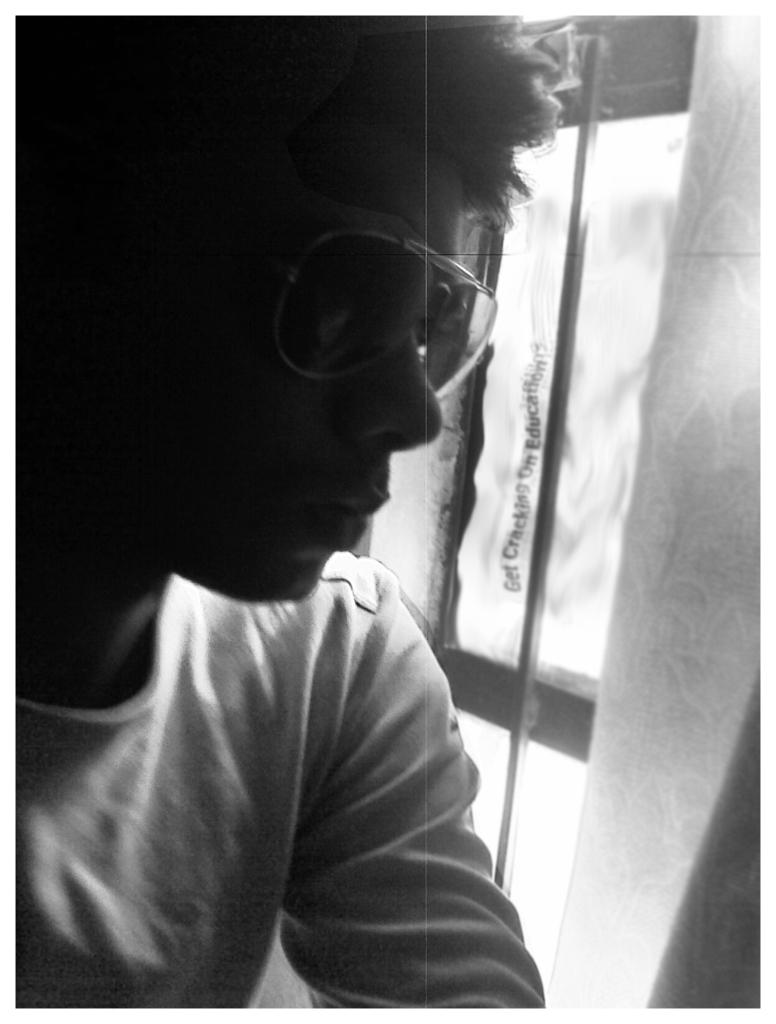Who or what is present in the image? There is a person in the image. What is behind the person in the image? There is a wooden glass door behind the person in the image. What type of apple is the person biting in the image? There is no apple or any indication of biting in the image. 